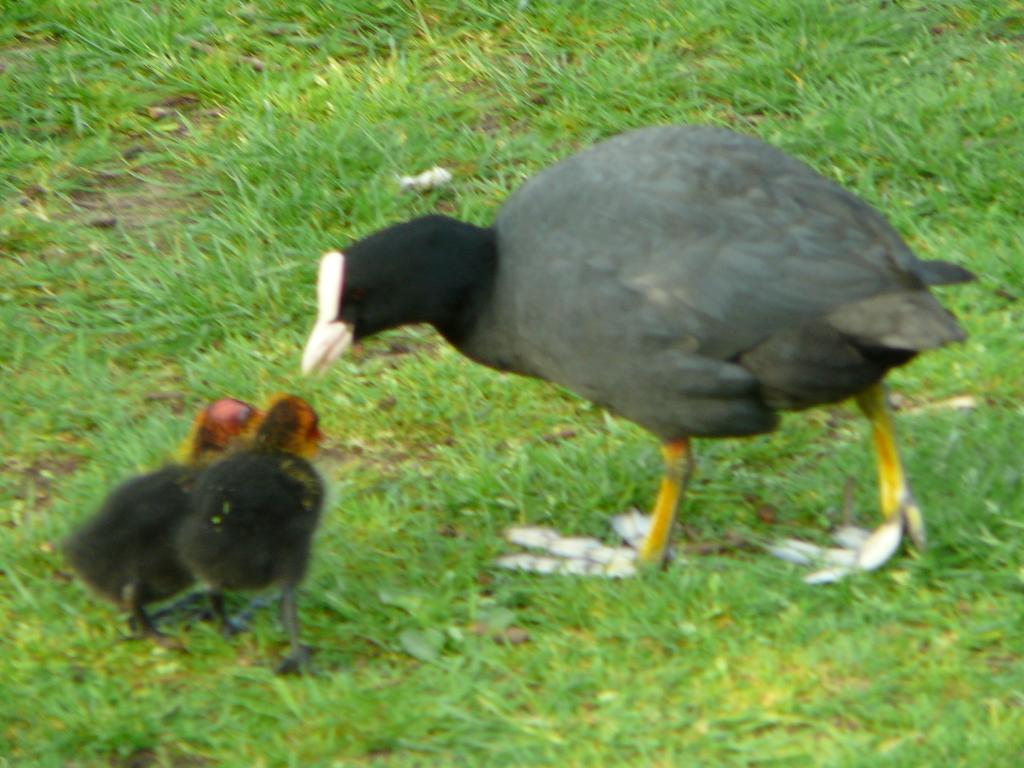What type of animals can be seen in the image? There are birds in the image. Where are the birds located? The birds are on the grass. What grade did the pigs receive in the image? There are no pigs present in the image, so it is not possible to determine their grade. 